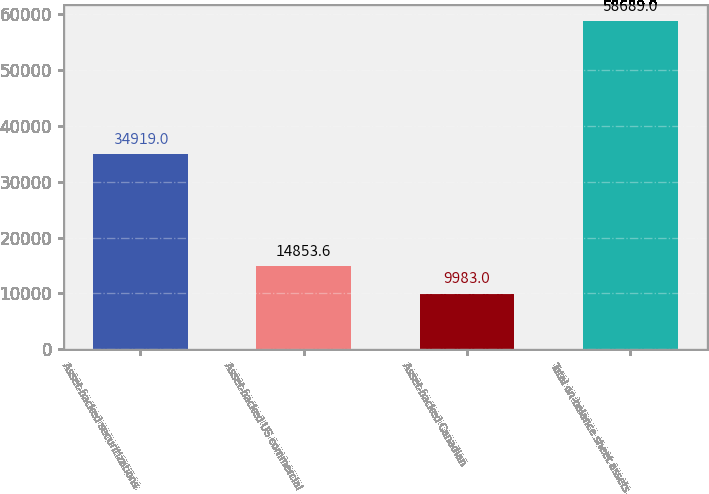Convert chart to OTSL. <chart><loc_0><loc_0><loc_500><loc_500><bar_chart><fcel>Asset-backed securitizations<fcel>Asset-backed US commercial<fcel>Asset-backed Canadian<fcel>Total on-balance sheet assets<nl><fcel>34919<fcel>14853.6<fcel>9983<fcel>58689<nl></chart> 